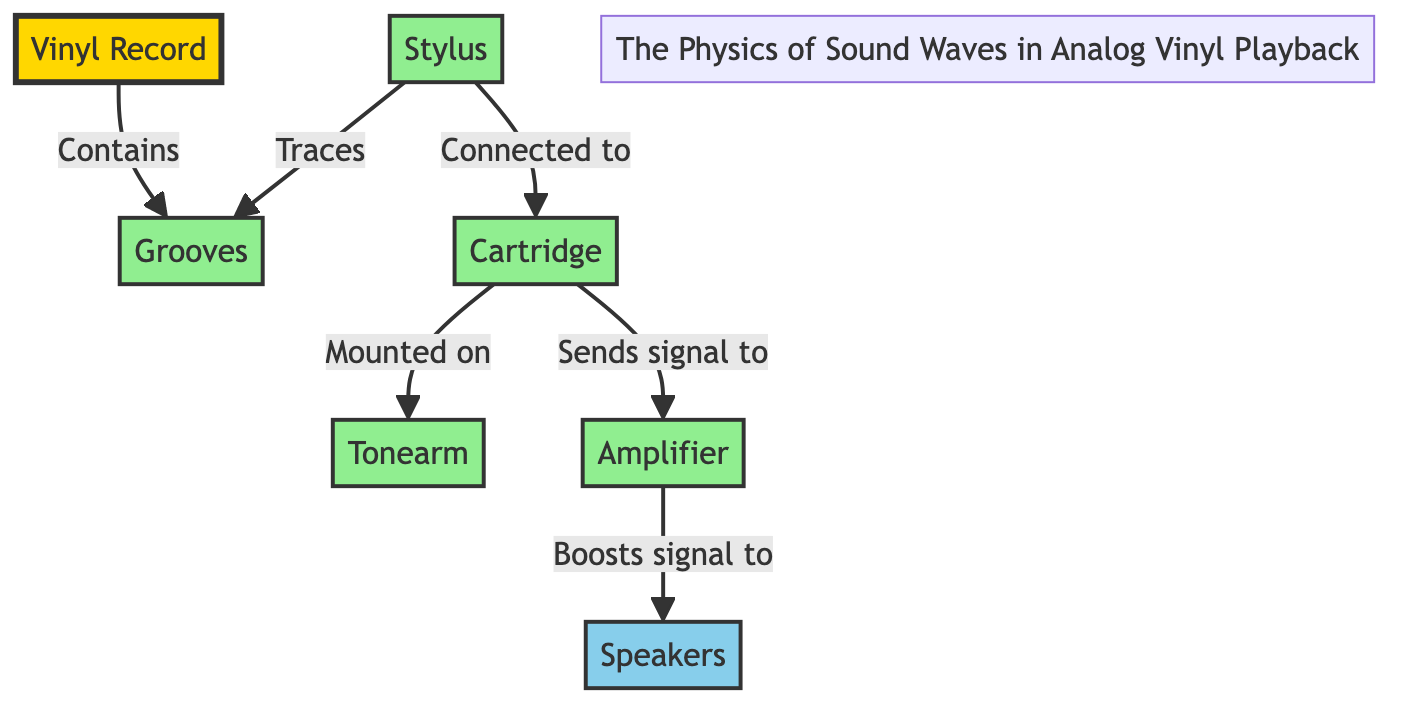What is the first component involved in vinyl playback? The first component mentioned is the "Vinyl Record," which is the initial source of sound in the playback process.
Answer: Vinyl Record What does the stylus do in the playback process? The diagram indicates that the stylus "Traces" the grooves on the vinyl record. This is a critical function as it physically reads the recorded sound.
Answer: Traces How many components are connected to the cartridge? According to the diagram, the cartridge is connected to two components: the stylus (which is also connected directly) and the tonearm. Thus, it has two direct connections shown.
Answer: 2 What component amplifies the signal before it reaches the speakers? The diagram specifies that the "Amplifier" is responsible for boosting the signal coming from the cartridge, which prepares it for output through the speakers.
Answer: Amplifier Which two components directly transmit sound signals? The "Cartridge" sends a signal to the "Amplifier," which is the next step in the signal chain before sound is produced through the speakers.
Answer: Cartridge, Amplifier What role does the tonearm play in analog vinyl playback? The tonearm is where the cartridge is mounted; thus, it serves as the support for the cartridge, facilitating the connection and trace of the stylus on the grooves.
Answer: Mounted on What is the final output of the playback process? The last component indicated in the playback chain is the "Speakers," which produces the audible sound after the signal has been amplified.
Answer: Speakers Which component is directly connected to the stylus? The diagram describes that the stylus is "Connected to" the cartridge, highlighting its role in reading the grooves.
Answer: Cartridge How does the signal flow from the vinyl record to the speakers? Starting from the Vinyl Record, the signal flows through the grooves, then to the stylus, continuing to the cartridge mounted on the tonearm, forwarded to the amplifier, and finally reaching the speakers.
Answer: Vinyl Record to Speakers 